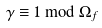Convert formula to latex. <formula><loc_0><loc_0><loc_500><loc_500>\gamma \equiv 1 \bmod \Omega _ { f }</formula> 